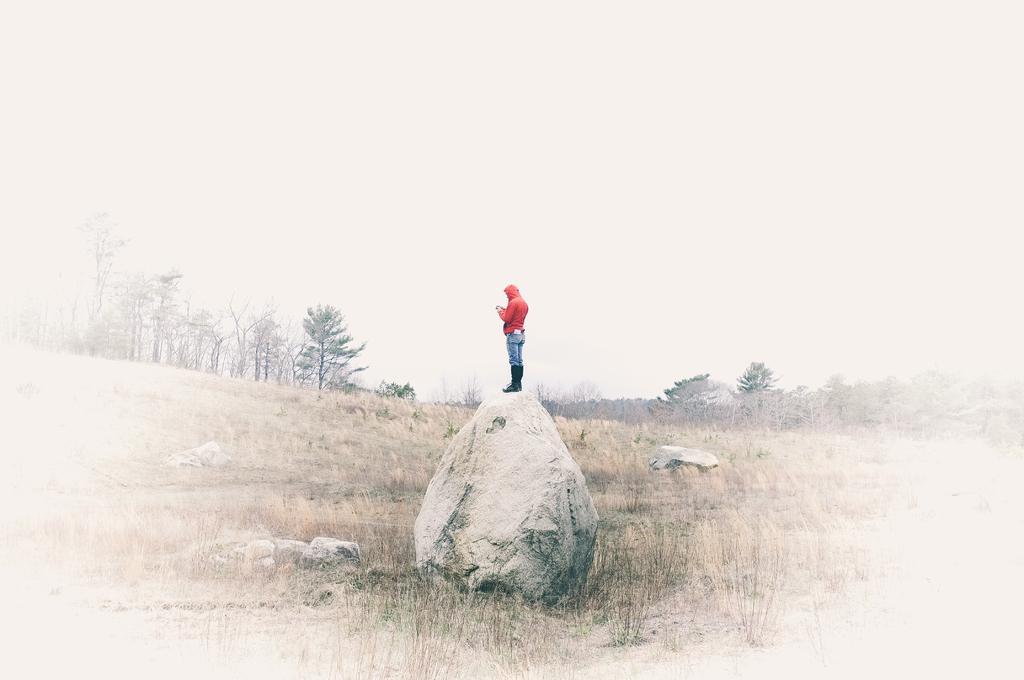In one or two sentences, can you explain what this image depicts? In this image I can see the person standing on the rock. I can see the person is wearing the red and blue color dress. I can see few more rocks and the plants. In the background I can see many trees and the sky. 